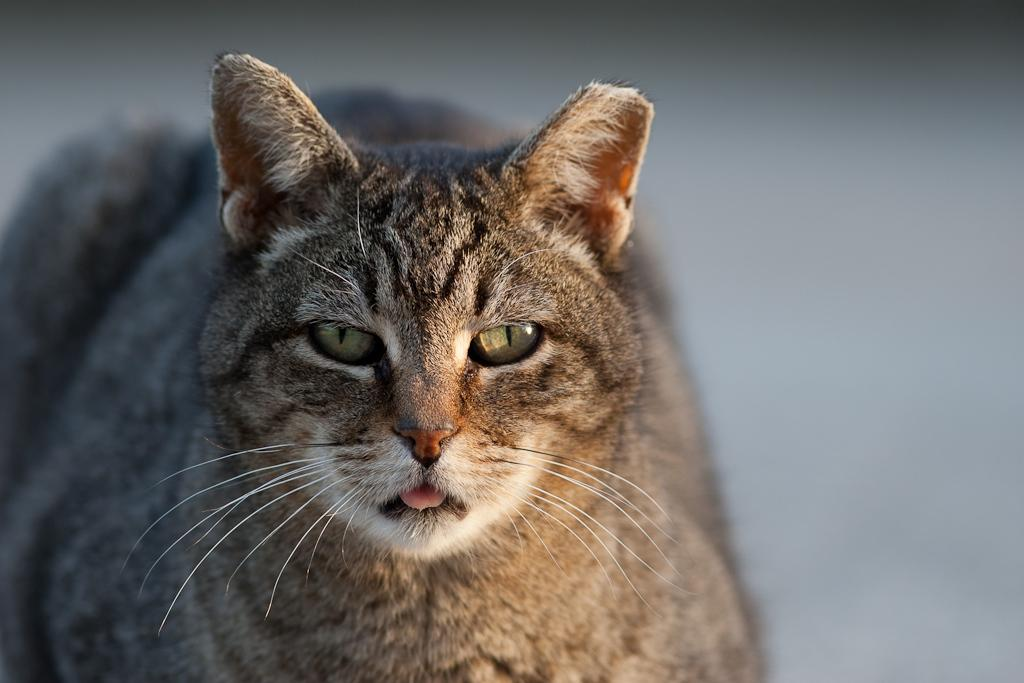What animal is present in the picture? There is a cat in the picture. Can you describe the color of the cat? The cat is brown and black in color. How is the cat depicted in the image? The cat is blurred in the background. Can you tell me how many times the cat has given birth in the image? There is no information about the cat's births in the image, as it only shows the cat's appearance and color. 